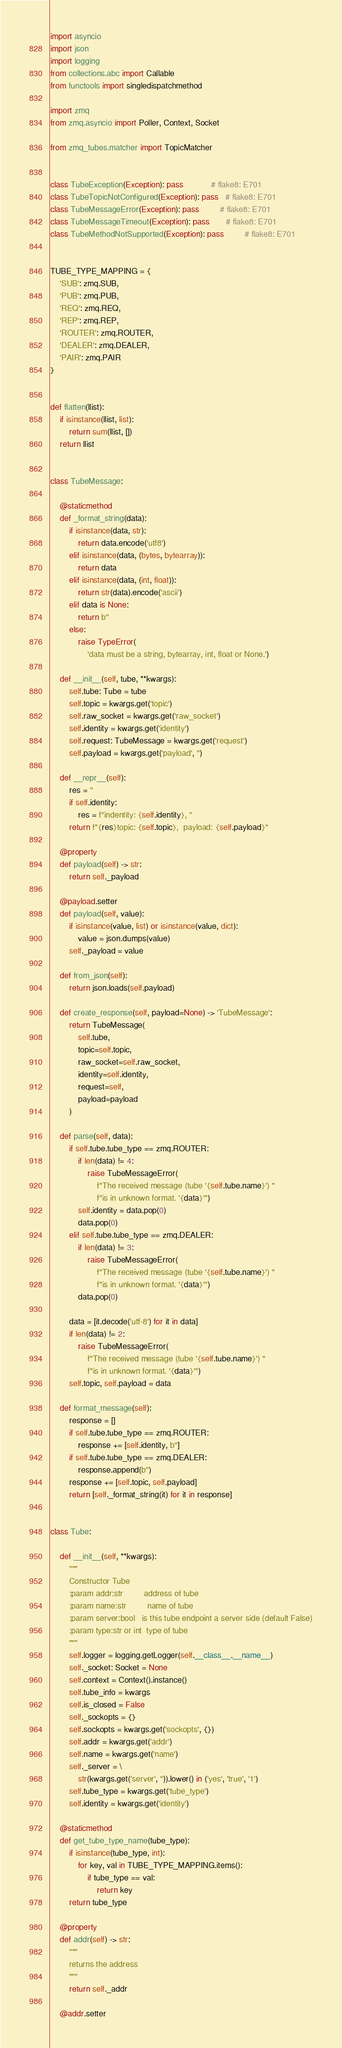Convert code to text. <code><loc_0><loc_0><loc_500><loc_500><_Python_>import asyncio
import json
import logging
from collections.abc import Callable
from functools import singledispatchmethod

import zmq
from zmq.asyncio import Poller, Context, Socket

from zmq_tubes.matcher import TopicMatcher


class TubeException(Exception): pass            # flake8: E701
class TubeTopicNotConfigured(Exception): pass   # flake8: E701
class TubeMessageError(Exception): pass         # flake8: E701
class TubeMessageTimeout(Exception): pass       # flake8: E701
class TubeMethodNotSupported(Exception): pass         # flake8: E701


TUBE_TYPE_MAPPING = {
    'SUB': zmq.SUB,
    'PUB': zmq.PUB,
    'REQ': zmq.REQ,
    'REP': zmq.REP,
    'ROUTER': zmq.ROUTER,
    'DEALER': zmq.DEALER,
    'PAIR': zmq.PAIR
}


def flatten(llist):
    if isinstance(llist, list):
        return sum(llist, [])
    return llist


class TubeMessage:

    @staticmethod
    def _format_string(data):
        if isinstance(data, str):
            return data.encode('utf8')
        elif isinstance(data, (bytes, bytearray)):
            return data
        elif isinstance(data, (int, float)):
            return str(data).encode('ascii')
        elif data is None:
            return b''
        else:
            raise TypeError(
                'data must be a string, bytearray, int, float or None.')

    def __init__(self, tube, **kwargs):
        self.tube: Tube = tube
        self.topic = kwargs.get('topic')
        self.raw_socket = kwargs.get('raw_socket')
        self.identity = kwargs.get('identity')
        self.request: TubeMessage = kwargs.get('request')
        self.payload = kwargs.get('payload', '')

    def __repr__(self):
        res = ''
        if self.identity:
            res = f"indentity: {self.identity}, "
        return f"{res}topic: {self.topic},  payload: {self.payload}"

    @property
    def payload(self) -> str:
        return self._payload

    @payload.setter
    def payload(self, value):
        if isinstance(value, list) or isinstance(value, dict):
            value = json.dumps(value)
        self._payload = value

    def from_json(self):
        return json.loads(self.payload)

    def create_response(self, payload=None) -> 'TubeMessage':
        return TubeMessage(
            self.tube,
            topic=self.topic,
            raw_socket=self.raw_socket,
            identity=self.identity,
            request=self,
            payload=payload
        )

    def parse(self, data):
        if self.tube.tube_type == zmq.ROUTER:
            if len(data) != 4:
                raise TubeMessageError(
                    f"The received message (tube '{self.tube.name}') "
                    f"is in unknown format. '{data}'")
            self.identity = data.pop(0)
            data.pop(0)
        elif self.tube.tube_type == zmq.DEALER:
            if len(data) != 3:
                raise TubeMessageError(
                    f"The received message (tube '{self.tube.name}') "
                    f"is in unknown format. '{data}'")
            data.pop(0)

        data = [it.decode('utf-8') for it in data]
        if len(data) != 2:
            raise TubeMessageError(
                f"The received message (tube '{self.tube.name}') "
                f"is in unknown format. '{data}'")
        self.topic, self.payload = data

    def format_message(self):
        response = []
        if self.tube.tube_type == zmq.ROUTER:
            response += [self.identity, b'']
        if self.tube.tube_type == zmq.DEALER:
            response.append(b'')
        response += [self.topic, self.payload]
        return [self._format_string(it) for it in response]


class Tube:

    def __init__(self, **kwargs):
        """
        Constructor Tube
        :param addr:str         address of tube
        :param name:str         name of tube
        :param server:bool   is this tube endpoint a server side (default False)
        :param type:str or int  type of tube
        """
        self.logger = logging.getLogger(self.__class__.__name__)
        self._socket: Socket = None
        self.context = Context().instance()
        self.tube_info = kwargs
        self.is_closed = False
        self._sockopts = {}
        self.sockopts = kwargs.get('sockopts', {})
        self.addr = kwargs.get('addr')
        self.name = kwargs.get('name')
        self._server = \
            str(kwargs.get('server', '')).lower() in ('yes', 'true', '1')
        self.tube_type = kwargs.get('tube_type')
        self.identity = kwargs.get('identity')

    @staticmethod
    def get_tube_type_name(tube_type):
        if isinstance(tube_type, int):
            for key, val in TUBE_TYPE_MAPPING.items():
                if tube_type == val:
                    return key
        return tube_type

    @property
    def addr(self) -> str:
        """
        returns the address
        """
        return self._addr

    @addr.setter</code> 